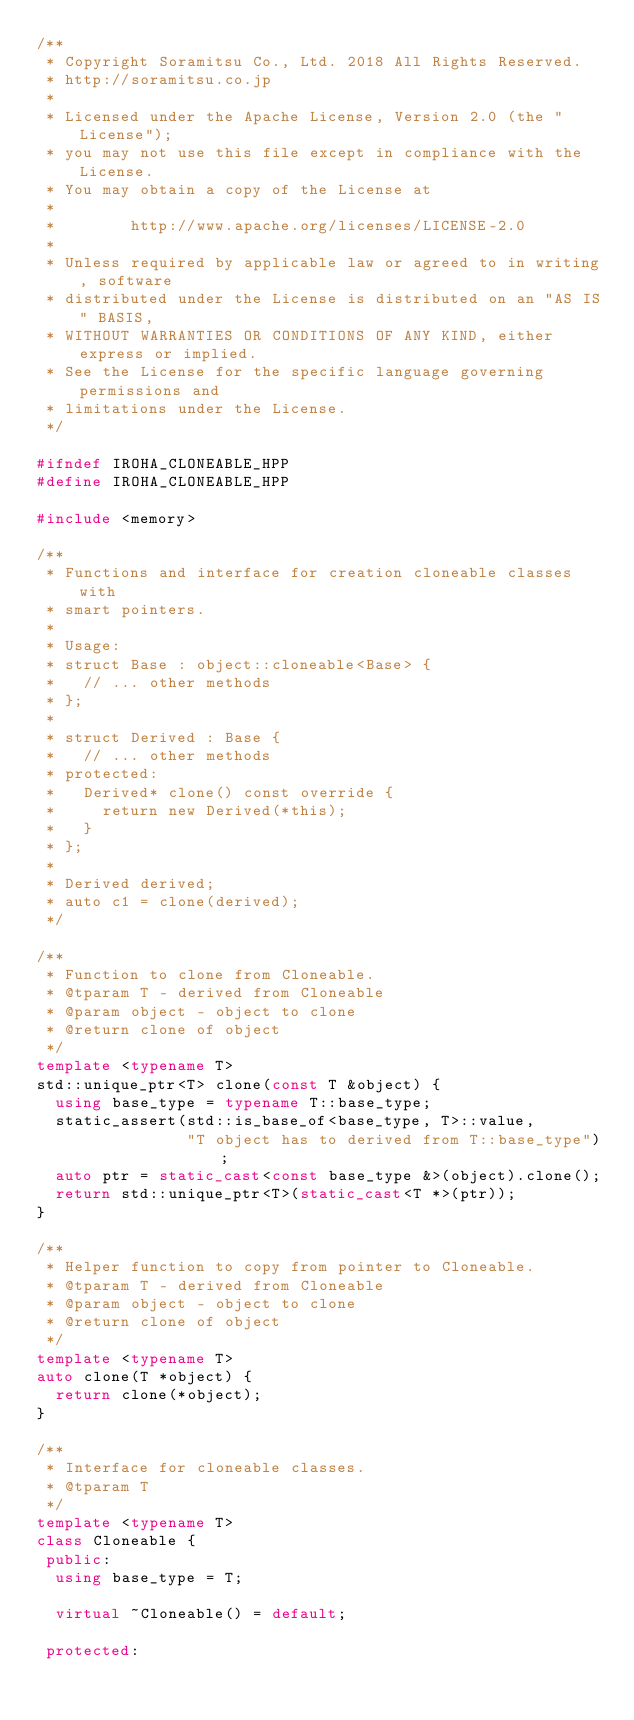Convert code to text. <code><loc_0><loc_0><loc_500><loc_500><_C++_>/**
 * Copyright Soramitsu Co., Ltd. 2018 All Rights Reserved.
 * http://soramitsu.co.jp
 *
 * Licensed under the Apache License, Version 2.0 (the "License");
 * you may not use this file except in compliance with the License.
 * You may obtain a copy of the License at
 *
 *        http://www.apache.org/licenses/LICENSE-2.0
 *
 * Unless required by applicable law or agreed to in writing, software
 * distributed under the License is distributed on an "AS IS" BASIS,
 * WITHOUT WARRANTIES OR CONDITIONS OF ANY KIND, either express or implied.
 * See the License for the specific language governing permissions and
 * limitations under the License.
 */

#ifndef IROHA_CLONEABLE_HPP
#define IROHA_CLONEABLE_HPP

#include <memory>

/**
 * Functions and interface for creation cloneable classes with
 * smart pointers.
 *
 * Usage:
 * struct Base : object::cloneable<Base> {
 *   // ... other methods
 * };
 *
 * struct Derived : Base {
 *   // ... other methods
 * protected:
 *   Derived* clone() const override {
 *     return new Derived(*this);
 *   }
 * };
 *
 * Derived derived;
 * auto c1 = clone(derived);
 */

/**
 * Function to clone from Cloneable.
 * @tparam T - derived from Cloneable
 * @param object - object to clone
 * @return clone of object
 */
template <typename T>
std::unique_ptr<T> clone(const T &object) {
  using base_type = typename T::base_type;
  static_assert(std::is_base_of<base_type, T>::value,
                "T object has to derived from T::base_type");
  auto ptr = static_cast<const base_type &>(object).clone();
  return std::unique_ptr<T>(static_cast<T *>(ptr));
}

/**
 * Helper function to copy from pointer to Cloneable.
 * @tparam T - derived from Cloneable
 * @param object - object to clone
 * @return clone of object
 */
template <typename T>
auto clone(T *object) {
  return clone(*object);
}

/**
 * Interface for cloneable classes.
 * @tparam T
 */
template <typename T>
class Cloneable {
 public:
  using base_type = T;

  virtual ~Cloneable() = default;

 protected:</code> 